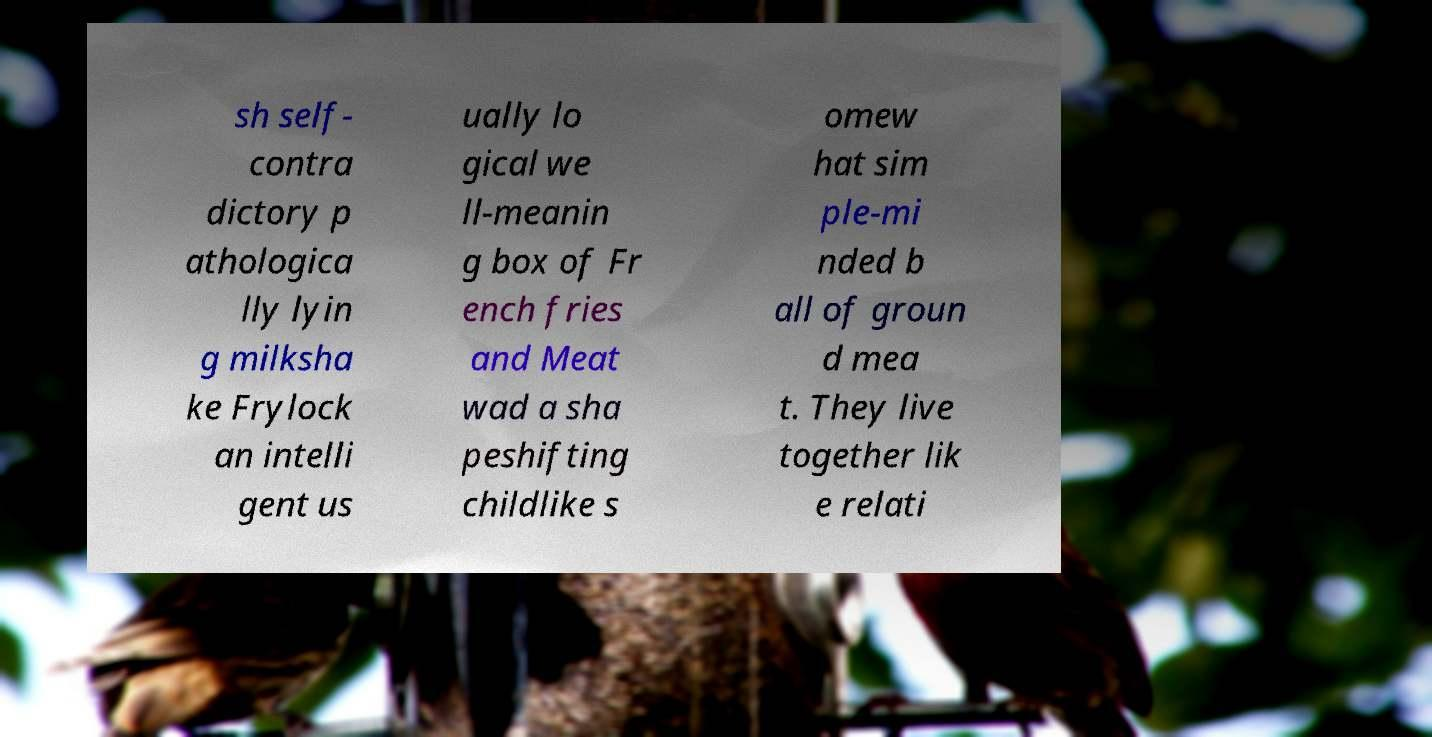Could you assist in decoding the text presented in this image and type it out clearly? sh self- contra dictory p athologica lly lyin g milksha ke Frylock an intelli gent us ually lo gical we ll-meanin g box of Fr ench fries and Meat wad a sha peshifting childlike s omew hat sim ple-mi nded b all of groun d mea t. They live together lik e relati 